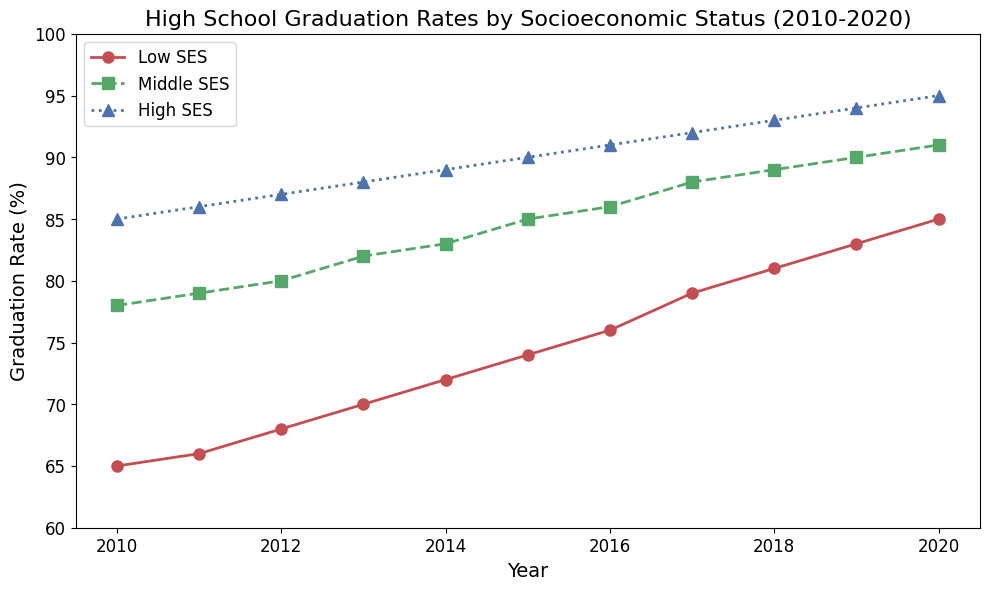What is the graduation rate for Low SES in 2015? Look for the data point for Low SES in the year 2015 on the plot. The red line representing Low SES intersects with 2015 at 74%.
Answer: 74% Which socioeconomic group had the highest graduation rate in 2020? Compare the graduation rates for all three groups (Low SES, Middle SES, High SES) in 2020. The blue line representing High SES is the highest at 95%.
Answer: High SES What is the difference in graduation rates between Low SES and High SES in 2015? Identify the graduation rates for Low SES (74%) and High SES (90%) in 2015, then calculate their difference (90% - 74% = 16%).
Answer: 16% Did the High SES graduation rate ever drop between 2010 and 2020? Observe the trend of the blue line (High SES) from 2010 to 2020. The line consistently moves upward, indicating no drop.
Answer: No What is the average graduation rate for Middle SES from 2015 to 2020? Calculate the average of the Middle SES graduation rates from 2015 to 2020: (85% + 86% + 88% + 89% + 90% + 91%) / 6 = 88.17%.
Answer: 88.17% By how much did the graduation rate increase for Low SES from 2010 to 2020? Calculate the increase in graduation rate for Low SES from 2010 (65%) to 2020 (85%): 85% - 65% = 20%.
Answer: 20% Which group had a greater rate of increase in graduation rates from 2010 to 2020, Low SES or Middle SES? Calculate the rate increase for both groups: Low SES increased by 20% (85% - 65%), and Middle SES increased by 13% (91% - 78%). Low SES had a greater increase.
Answer: Low SES In which year did Middle SES first surpass an 85% graduation rate? Find the first year where the green line (Middle SES) crosses above the 85% mark. The year is 2015 when the rate is exactly 85%.
Answer: 2015 How does the graduation rate trend for High SES compare visually to the other groups? Observe the overall trend lines: The blue line (High SES) consistently remains above the other lines, showing a steady upward trend similar to the others but at higher values.
Answer: Steady upward, highest trend What was the graduation rate for Low SES in 2013? Locate the data point for Low SES in the year 2013 on the plot. The red line representing Low SES intersects with 2013 at 70%.
Answer: 70% 